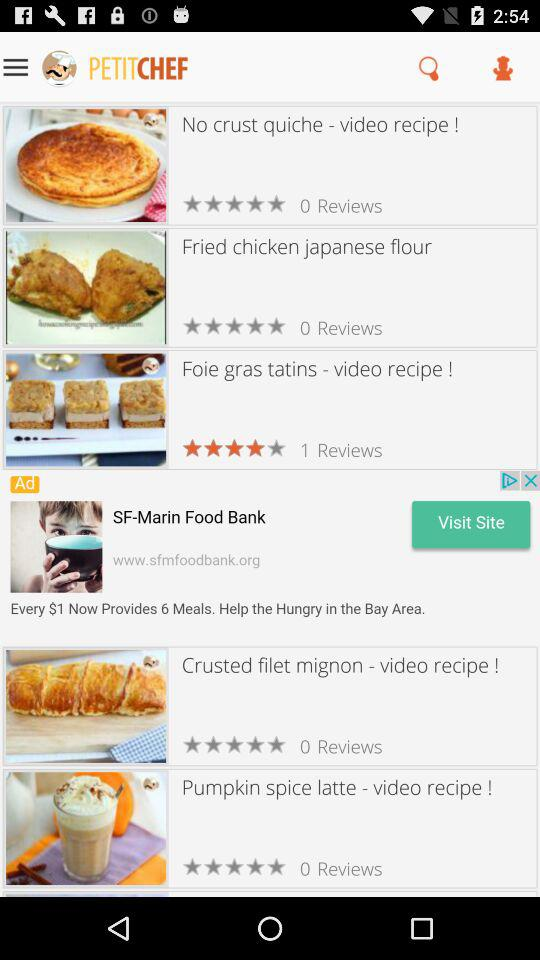What is the number of reviews of the "Pumpkin spice latte"? The number of reviews is 0. 